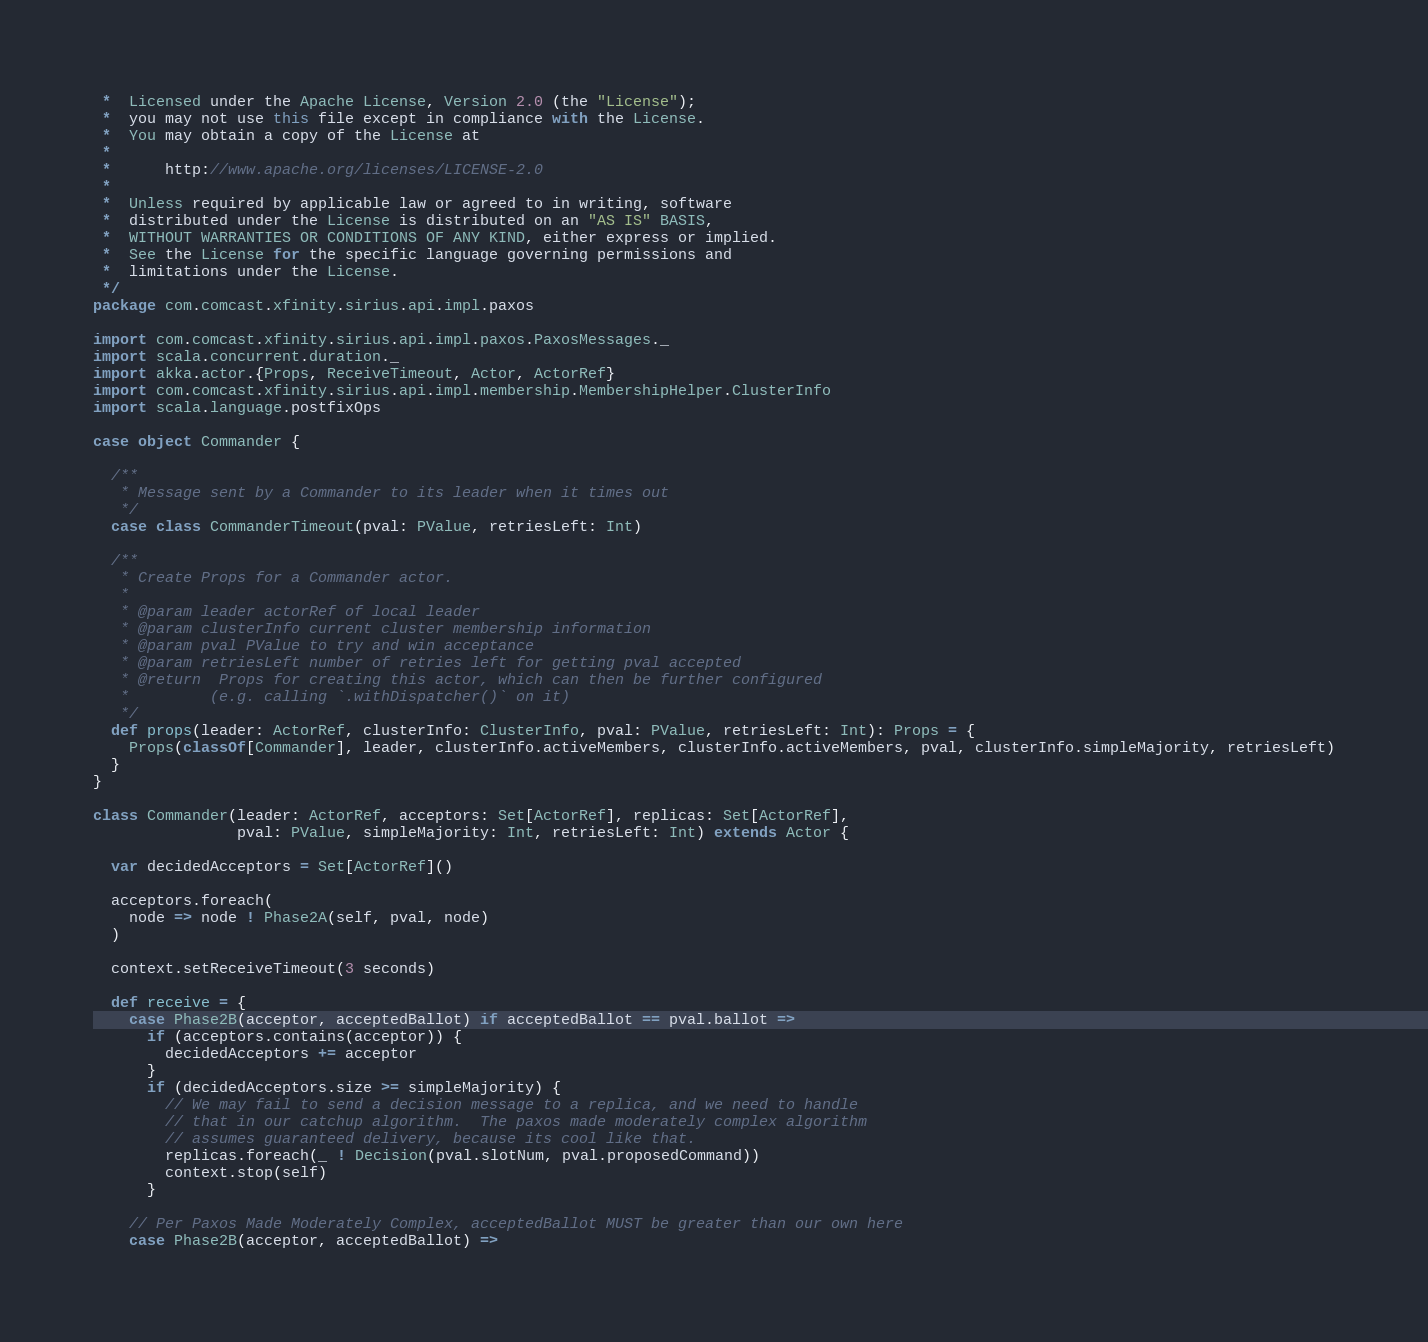<code> <loc_0><loc_0><loc_500><loc_500><_Scala_> *  Licensed under the Apache License, Version 2.0 (the "License");
 *  you may not use this file except in compliance with the License.
 *  You may obtain a copy of the License at
 *
 *      http://www.apache.org/licenses/LICENSE-2.0
 *
 *  Unless required by applicable law or agreed to in writing, software
 *  distributed under the License is distributed on an "AS IS" BASIS,
 *  WITHOUT WARRANTIES OR CONDITIONS OF ANY KIND, either express or implied.
 *  See the License for the specific language governing permissions and
 *  limitations under the License.
 */
package com.comcast.xfinity.sirius.api.impl.paxos

import com.comcast.xfinity.sirius.api.impl.paxos.PaxosMessages._
import scala.concurrent.duration._
import akka.actor.{Props, ReceiveTimeout, Actor, ActorRef}
import com.comcast.xfinity.sirius.api.impl.membership.MembershipHelper.ClusterInfo
import scala.language.postfixOps

case object Commander {

  /**
   * Message sent by a Commander to its leader when it times out
   */
  case class CommanderTimeout(pval: PValue, retriesLeft: Int)

  /**
   * Create Props for a Commander actor.
   *
   * @param leader actorRef of local leader
   * @param clusterInfo current cluster membership information
   * @param pval PValue to try and win acceptance
   * @param retriesLeft number of retries left for getting pval accepted
   * @return  Props for creating this actor, which can then be further configured
   *         (e.g. calling `.withDispatcher()` on it)
   */
  def props(leader: ActorRef, clusterInfo: ClusterInfo, pval: PValue, retriesLeft: Int): Props = {
    Props(classOf[Commander], leader, clusterInfo.activeMembers, clusterInfo.activeMembers, pval, clusterInfo.simpleMajority, retriesLeft)
  }
}

class Commander(leader: ActorRef, acceptors: Set[ActorRef], replicas: Set[ActorRef],
                pval: PValue, simpleMajority: Int, retriesLeft: Int) extends Actor {

  var decidedAcceptors = Set[ActorRef]()

  acceptors.foreach(
    node => node ! Phase2A(self, pval, node)
  )

  context.setReceiveTimeout(3 seconds)

  def receive = {
    case Phase2B(acceptor, acceptedBallot) if acceptedBallot == pval.ballot =>
      if (acceptors.contains(acceptor)) {
        decidedAcceptors += acceptor
      }
      if (decidedAcceptors.size >= simpleMajority) {
        // We may fail to send a decision message to a replica, and we need to handle
        // that in our catchup algorithm.  The paxos made moderately complex algorithm
        // assumes guaranteed delivery, because its cool like that.
        replicas.foreach(_ ! Decision(pval.slotNum, pval.proposedCommand))
        context.stop(self)
      }

    // Per Paxos Made Moderately Complex, acceptedBallot MUST be greater than our own here
    case Phase2B(acceptor, acceptedBallot) =></code> 